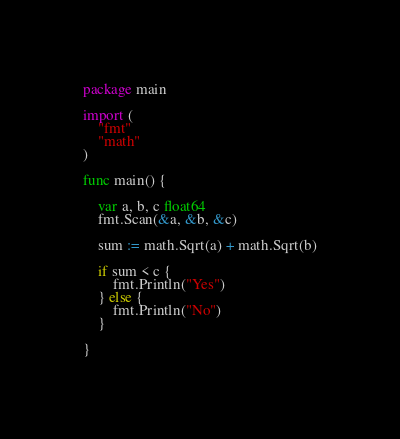Convert code to text. <code><loc_0><loc_0><loc_500><loc_500><_Go_>package main

import (
	"fmt"
	"math"
)

func main() {

	var a, b, c float64
	fmt.Scan(&a, &b, &c)

	sum := math.Sqrt(a) + math.Sqrt(b)

	if sum < c {
		fmt.Println("Yes")
	} else {
		fmt.Println("No")
	}

}
</code> 